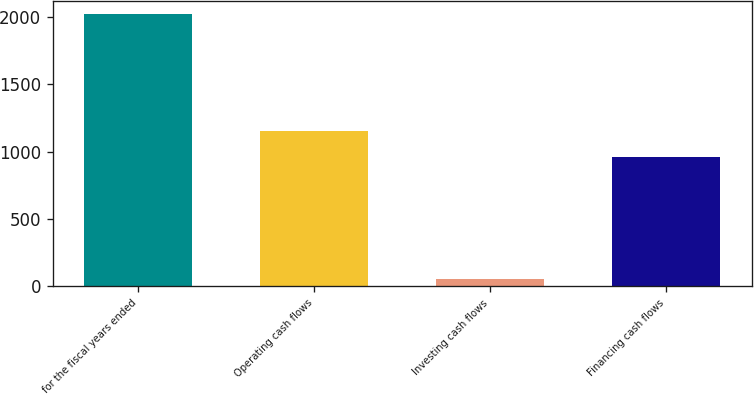Convert chart. <chart><loc_0><loc_0><loc_500><loc_500><bar_chart><fcel>for the fiscal years ended<fcel>Operating cash flows<fcel>Investing cash flows<fcel>Financing cash flows<nl><fcel>2017<fcel>1152.5<fcel>52<fcel>956<nl></chart> 